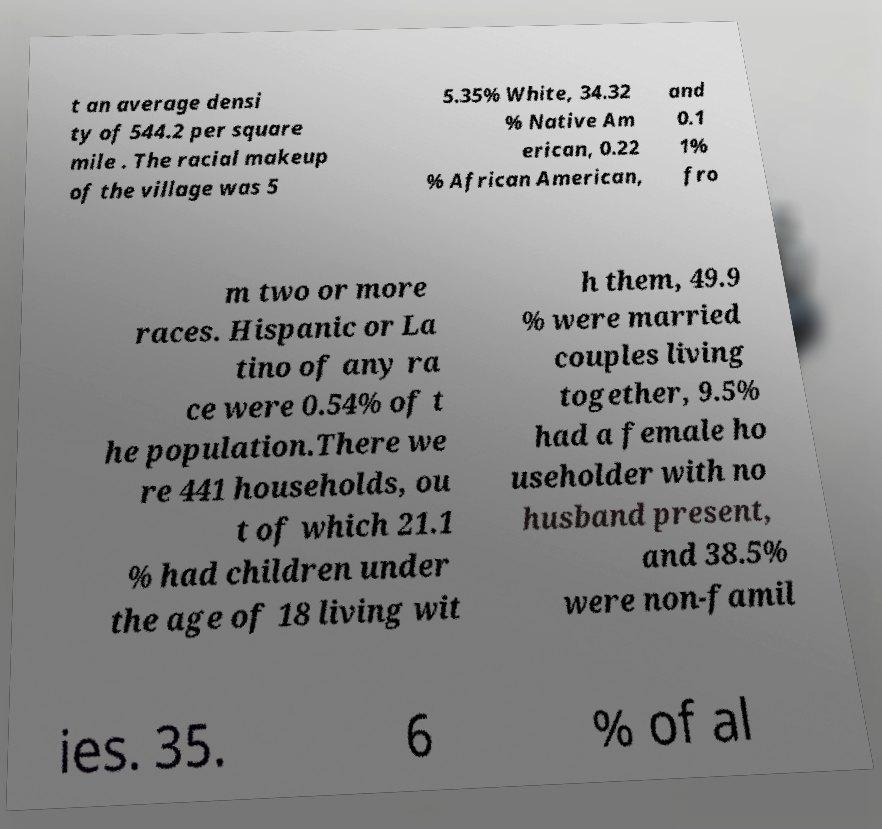For documentation purposes, I need the text within this image transcribed. Could you provide that? t an average densi ty of 544.2 per square mile . The racial makeup of the village was 5 5.35% White, 34.32 % Native Am erican, 0.22 % African American, and 0.1 1% fro m two or more races. Hispanic or La tino of any ra ce were 0.54% of t he population.There we re 441 households, ou t of which 21.1 % had children under the age of 18 living wit h them, 49.9 % were married couples living together, 9.5% had a female ho useholder with no husband present, and 38.5% were non-famil ies. 35. 6 % of al 